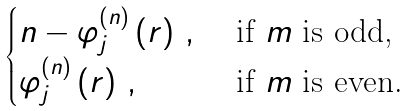Convert formula to latex. <formula><loc_0><loc_0><loc_500><loc_500>\begin{cases} n - \varphi _ { j } ^ { ( n ) } \left ( r \right ) \, , & \text { if $m$ is odd,} \\ \varphi _ { j } ^ { ( n ) } \left ( r \right ) \, , & \text { if $m$ is even.} \end{cases}</formula> 